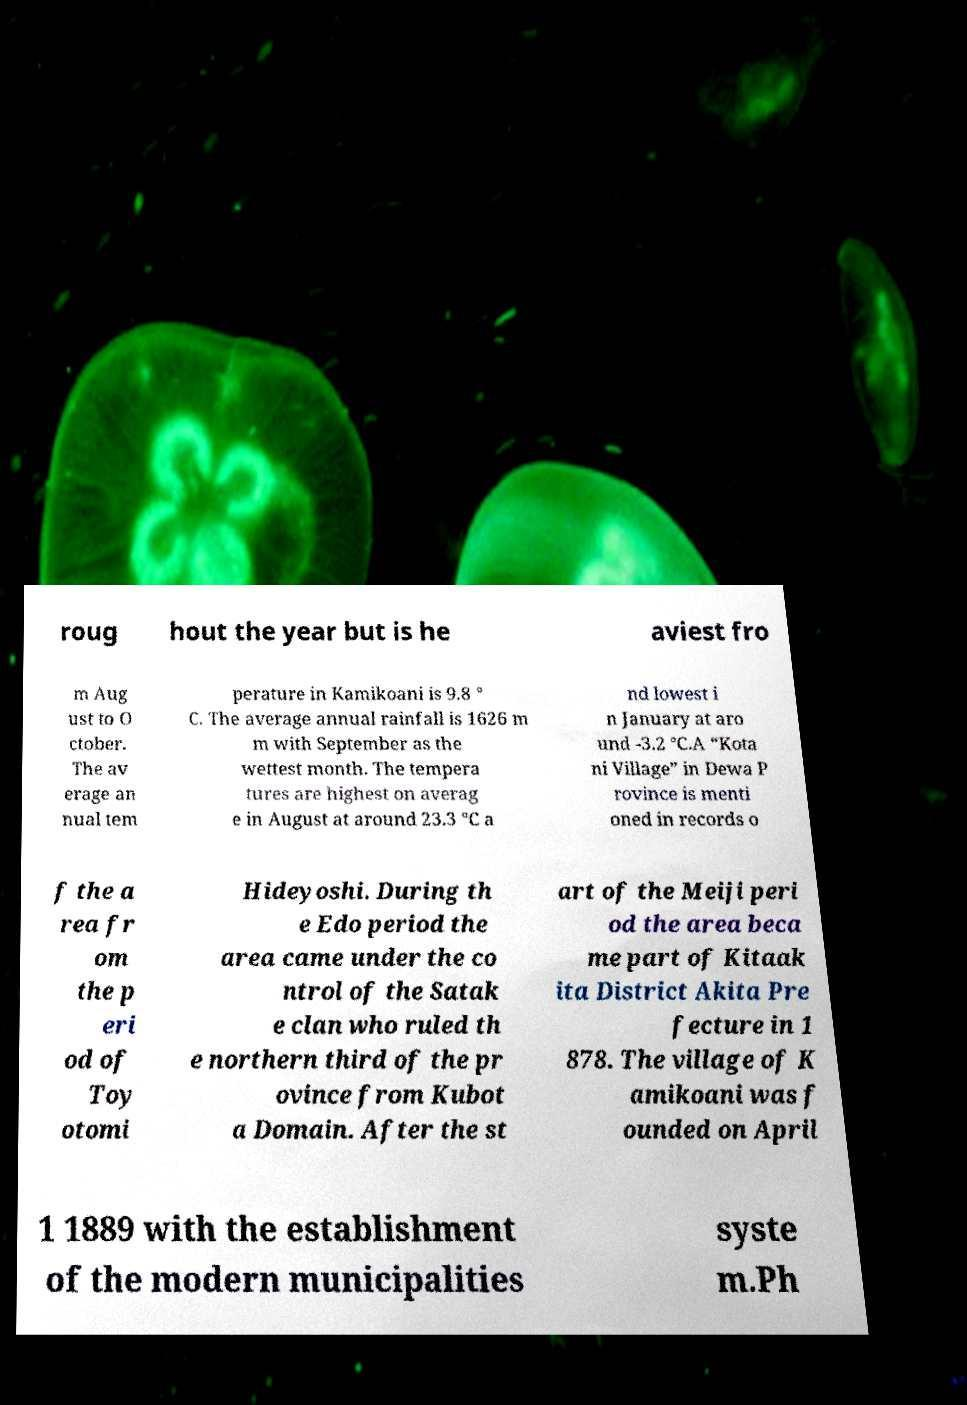There's text embedded in this image that I need extracted. Can you transcribe it verbatim? roug hout the year but is he aviest fro m Aug ust to O ctober. The av erage an nual tem perature in Kamikoani is 9.8 ° C. The average annual rainfall is 1626 m m with September as the wettest month. The tempera tures are highest on averag e in August at around 23.3 °C a nd lowest i n January at aro und -3.2 °C.A “Kota ni Village” in Dewa P rovince is menti oned in records o f the a rea fr om the p eri od of Toy otomi Hideyoshi. During th e Edo period the area came under the co ntrol of the Satak e clan who ruled th e northern third of the pr ovince from Kubot a Domain. After the st art of the Meiji peri od the area beca me part of Kitaak ita District Akita Pre fecture in 1 878. The village of K amikoani was f ounded on April 1 1889 with the establishment of the modern municipalities syste m.Ph 